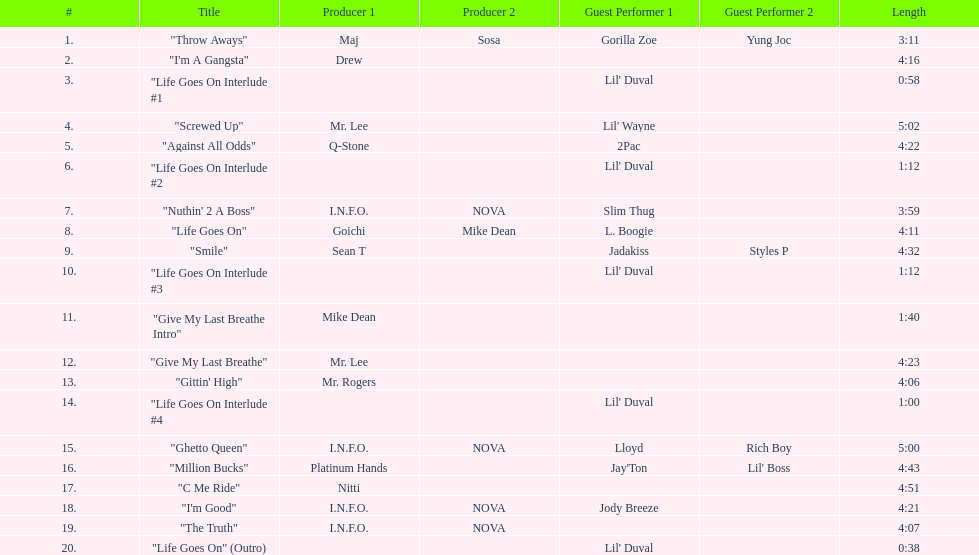What is the number of tracks featuring 2pac? 1. 